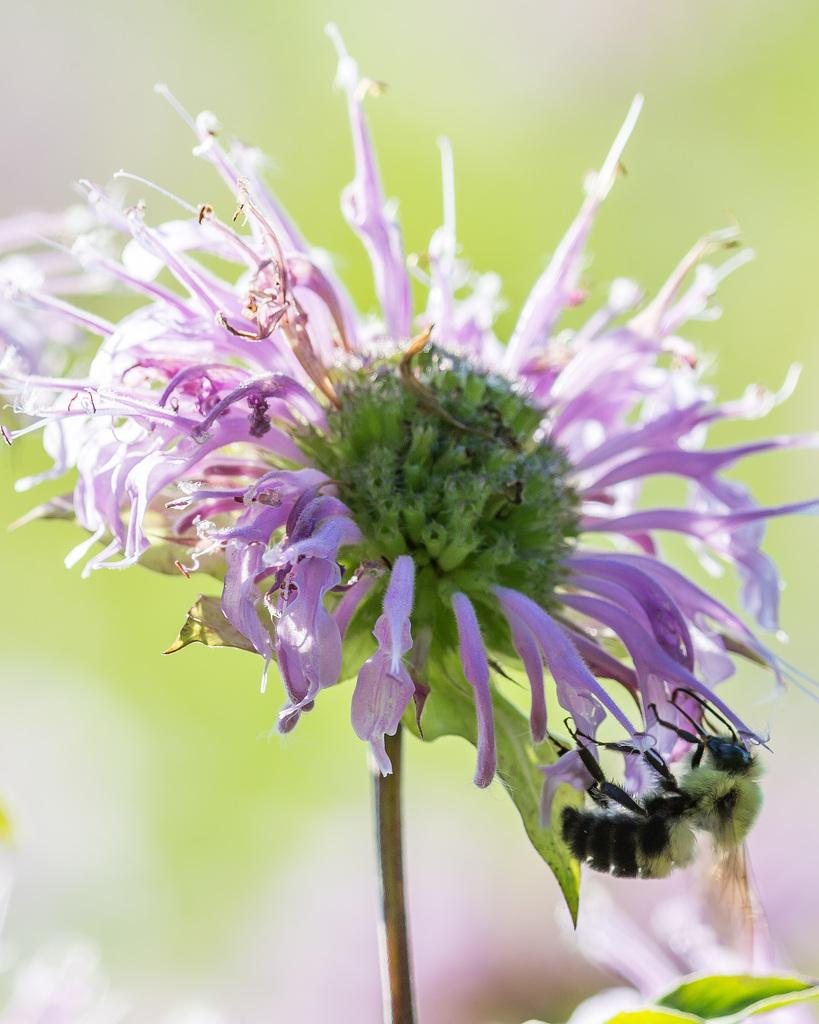What type of flower is present in the image? There is a pink flower in the image. Are there any other living organisms visible in the image? Yes, there is a fly or insect on the bottom right of the image. What plant part can be seen in addition to the flower? There is a leaf visible in the image. What type of coat is the oatmeal wearing in the image? There is no oatmeal or coat present in the image. 